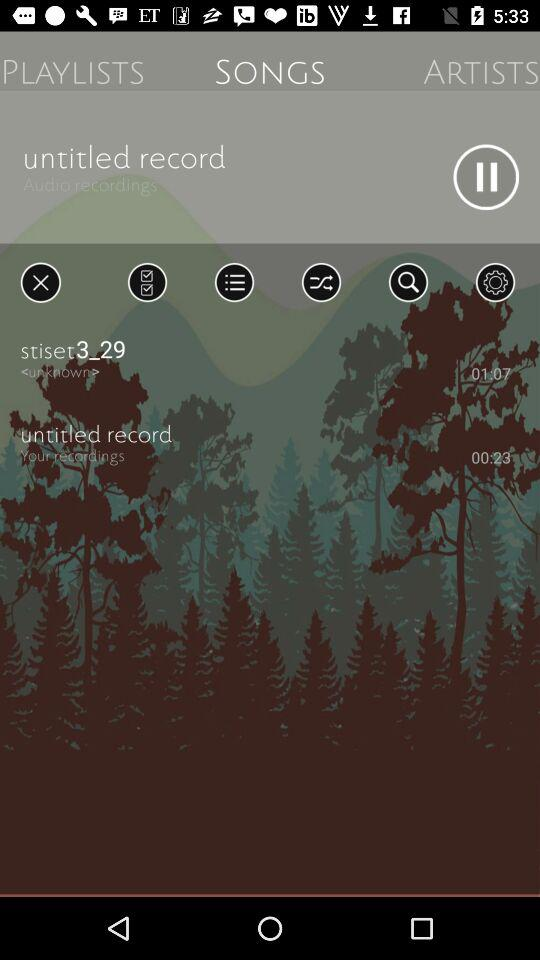What is the duration of the untitled record? The duration is 23 seconds. 